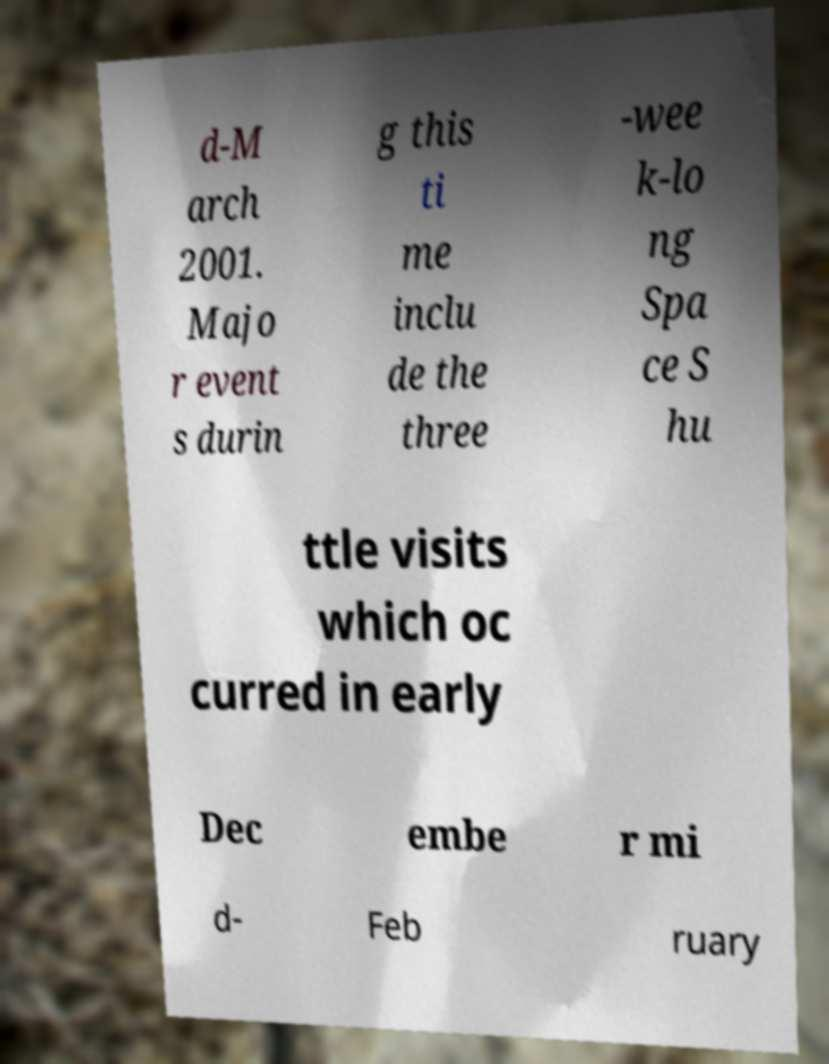Could you extract and type out the text from this image? d-M arch 2001. Majo r event s durin g this ti me inclu de the three -wee k-lo ng Spa ce S hu ttle visits which oc curred in early Dec embe r mi d- Feb ruary 